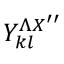<formula> <loc_0><loc_0><loc_500><loc_500>Y _ { k l } ^ { \Lambda X ^ { \prime \prime } }</formula> 